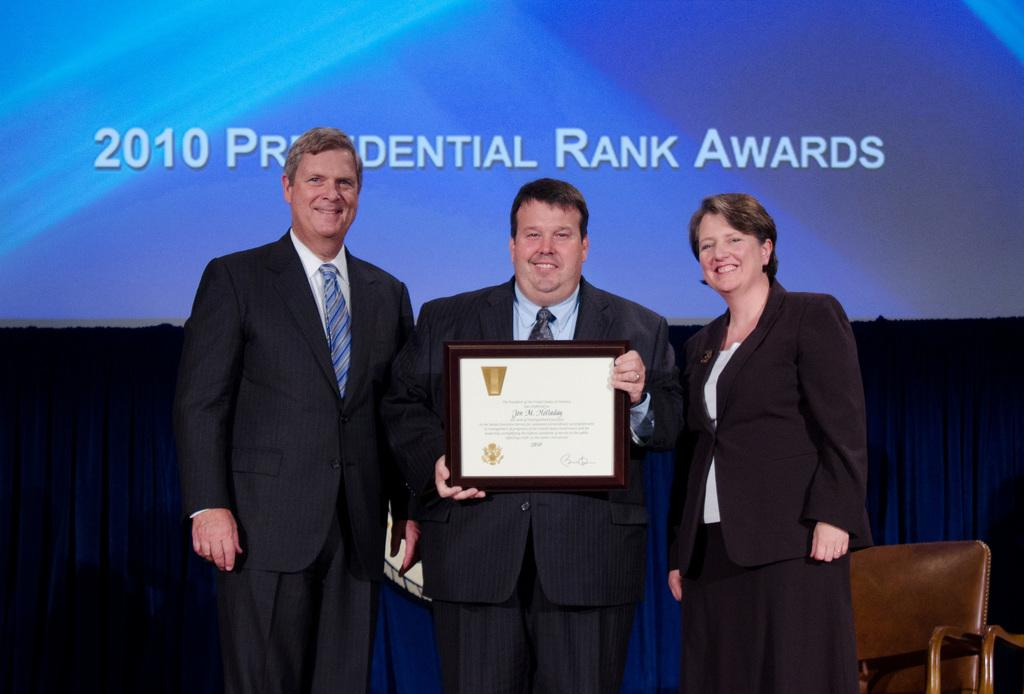How many people are in the image? There are two men and a woman standing in the image. What is one of the men holding in his hands? One of the men is holding a framed certificate in his hands. What can be seen in the background of the image? There is a screen, a cloth, and a chair in the background of the image. What is the woman's suggestion in the image? There is no mention of a suggestion or any conversation in the image. 